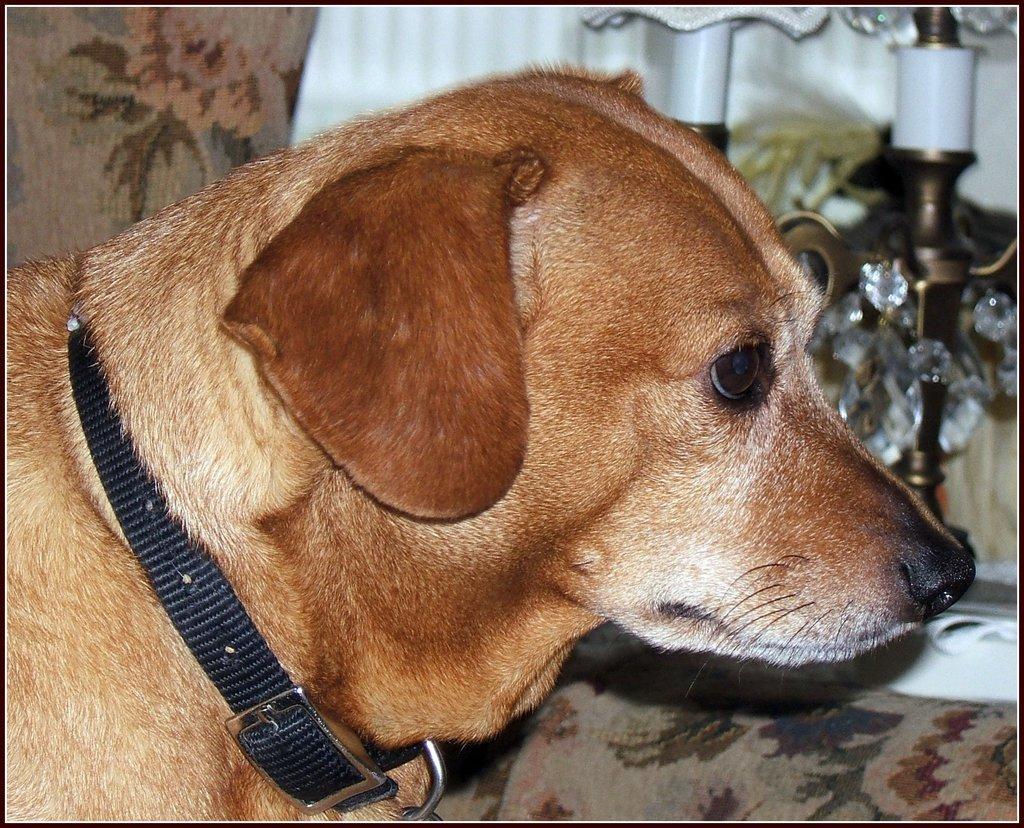Can you describe this image briefly? In the center of the image, we can see a dog with a belt is on the couch and in the background, there are lights and there is a curtain. 